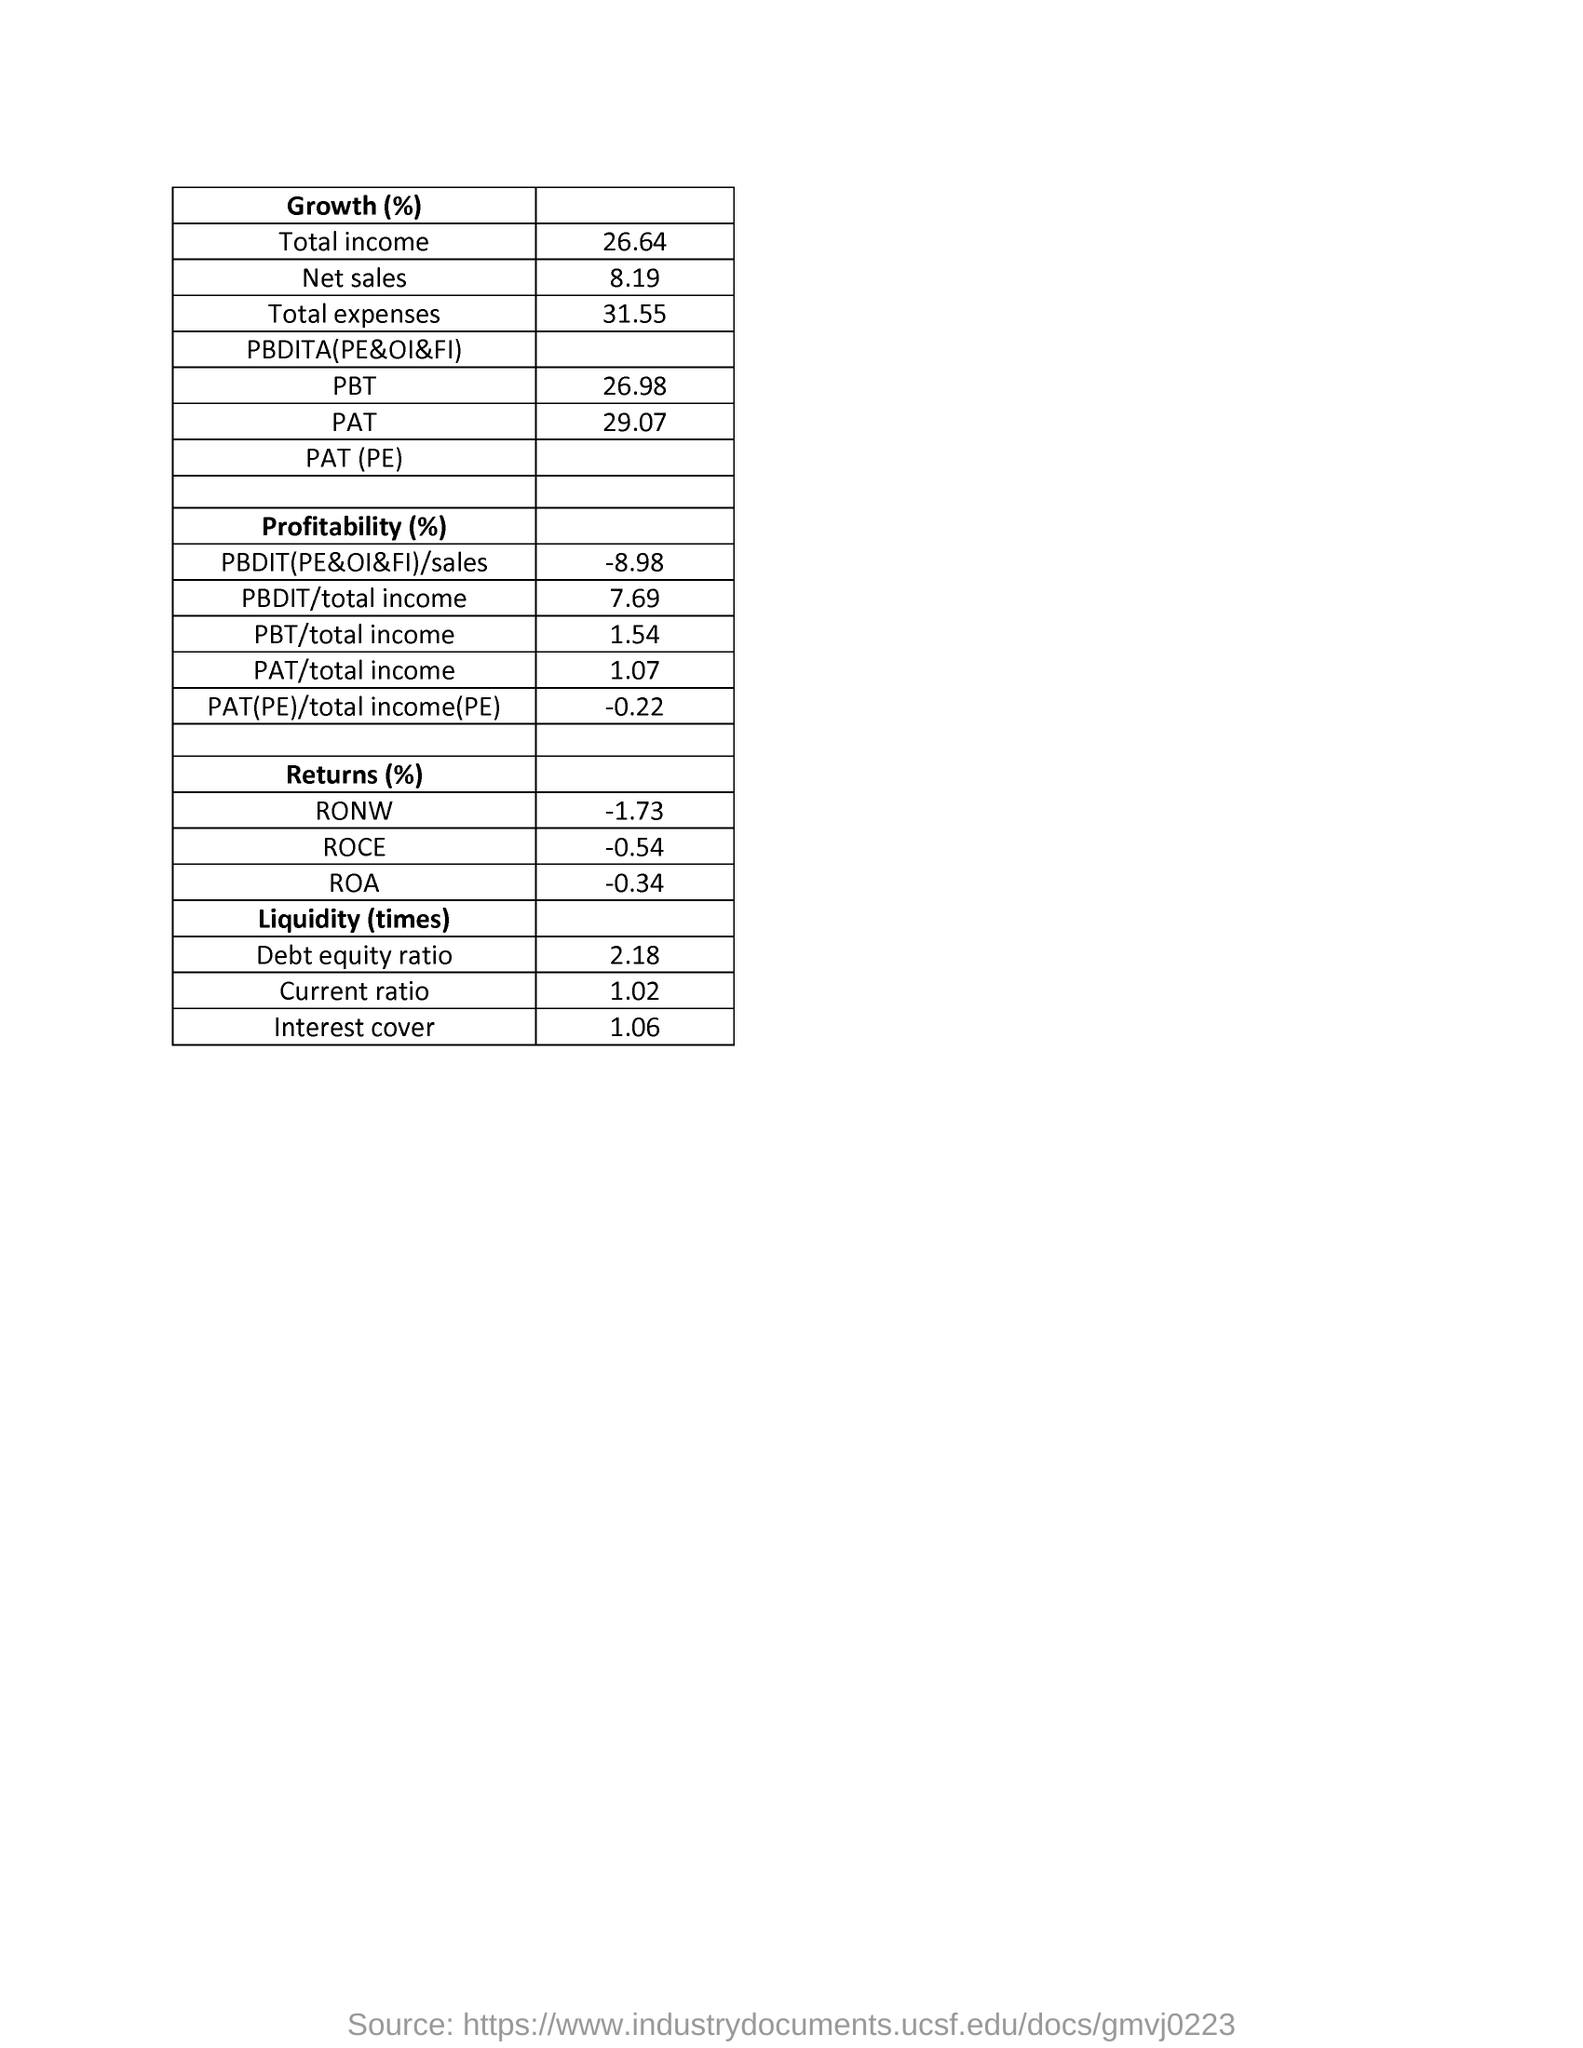What is the total income mentioned in the document?
Your answer should be very brief. 26.64. What is the debt equity ratio mentioned in the document?
Offer a very short reply. 2.18%. What is the total expenses mentioned in the document?
Your answer should be compact. 31.55%. 